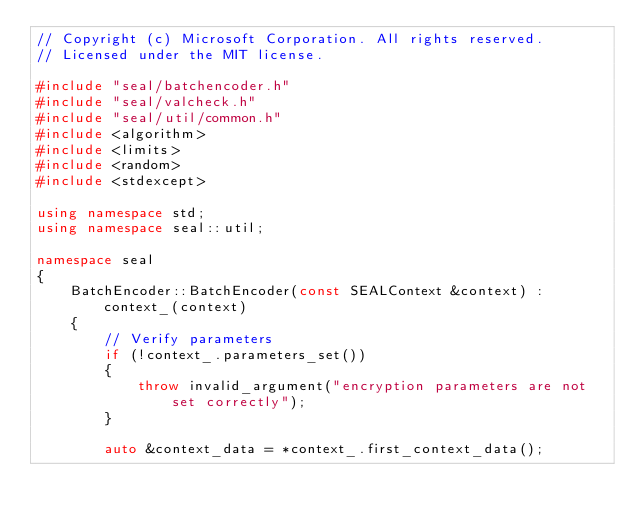Convert code to text. <code><loc_0><loc_0><loc_500><loc_500><_C++_>// Copyright (c) Microsoft Corporation. All rights reserved.
// Licensed under the MIT license.

#include "seal/batchencoder.h"
#include "seal/valcheck.h"
#include "seal/util/common.h"
#include <algorithm>
#include <limits>
#include <random>
#include <stdexcept>

using namespace std;
using namespace seal::util;

namespace seal
{
    BatchEncoder::BatchEncoder(const SEALContext &context) : context_(context)
    {
        // Verify parameters
        if (!context_.parameters_set())
        {
            throw invalid_argument("encryption parameters are not set correctly");
        }

        auto &context_data = *context_.first_context_data();</code> 